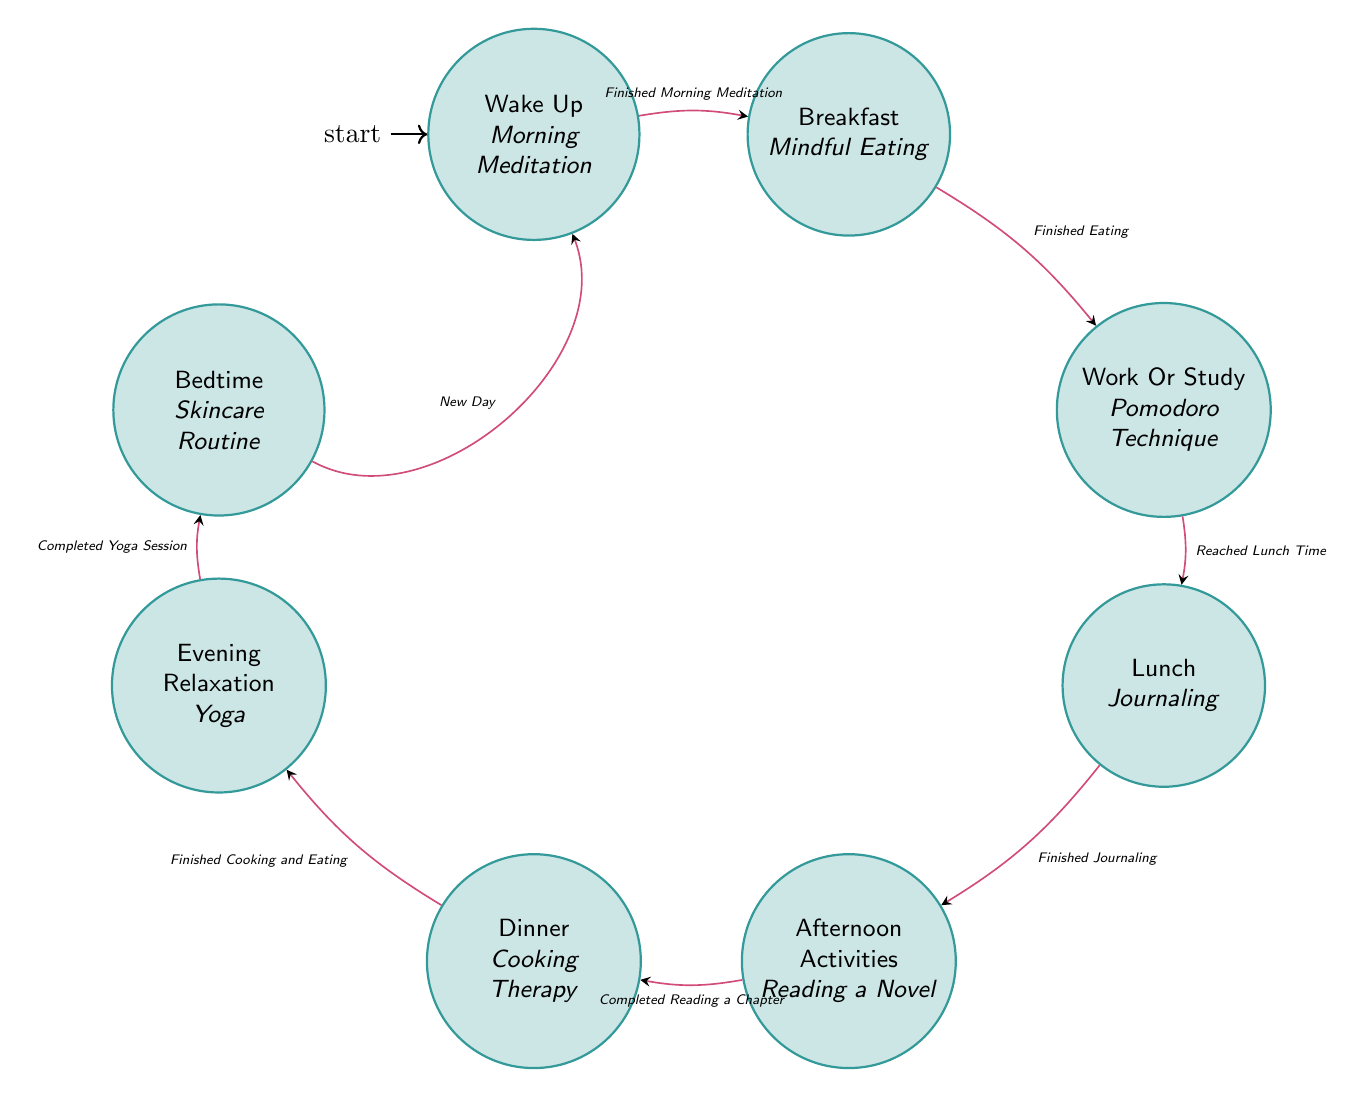What is the first self-care activity of the day? The first state in the diagram is "Wake Up," which indicates that the self-care activity during this time is "Morning Meditation."
Answer: Morning Meditation How many self-care activities are represented in the diagram? The diagram contains eight states, each associated with a self-care activity, thus representing a total of eight self-care activities.
Answer: 8 What transition triggers the movement from Breakfast to Work Or Study? The arrow from the "Breakfast" state to the "Work Or Study" state indicates that the transition occurs when the trigger is "Finished Eating."
Answer: Finished Eating What is the last self-care activity before Bedtime? The state directly before "Bedtime" is "Evening Relaxation," which corresponds with the self-care activity known as "Yoga."
Answer: Yoga What is the relationship between Lunch and Afternoon Activities? The diagram shows a transition from the "Lunch" state to "Afternoon Activities" state, indicating that the trigger for this transition is "Finished Journaling."
Answer: Finished Journaling If someone completes Yoga, what is the next state they enter? Upon completing the "Evening Relaxation" state, where Yoga is practiced, the transition leads to the "Bedtime" state as indicated on the diagram.
Answer: Bedtime What self-care activity is performed at Dinner? In the "Dinner" state, the associated self-care activity is "Cooking Therapy," as noted in the diagram.
Answer: Cooking Therapy Which state involves balanced work with leisure? The state called "Afternoon Activities" is specifically associated with balancing work and leisure as described in the diagram.
Answer: Afternoon Activities 